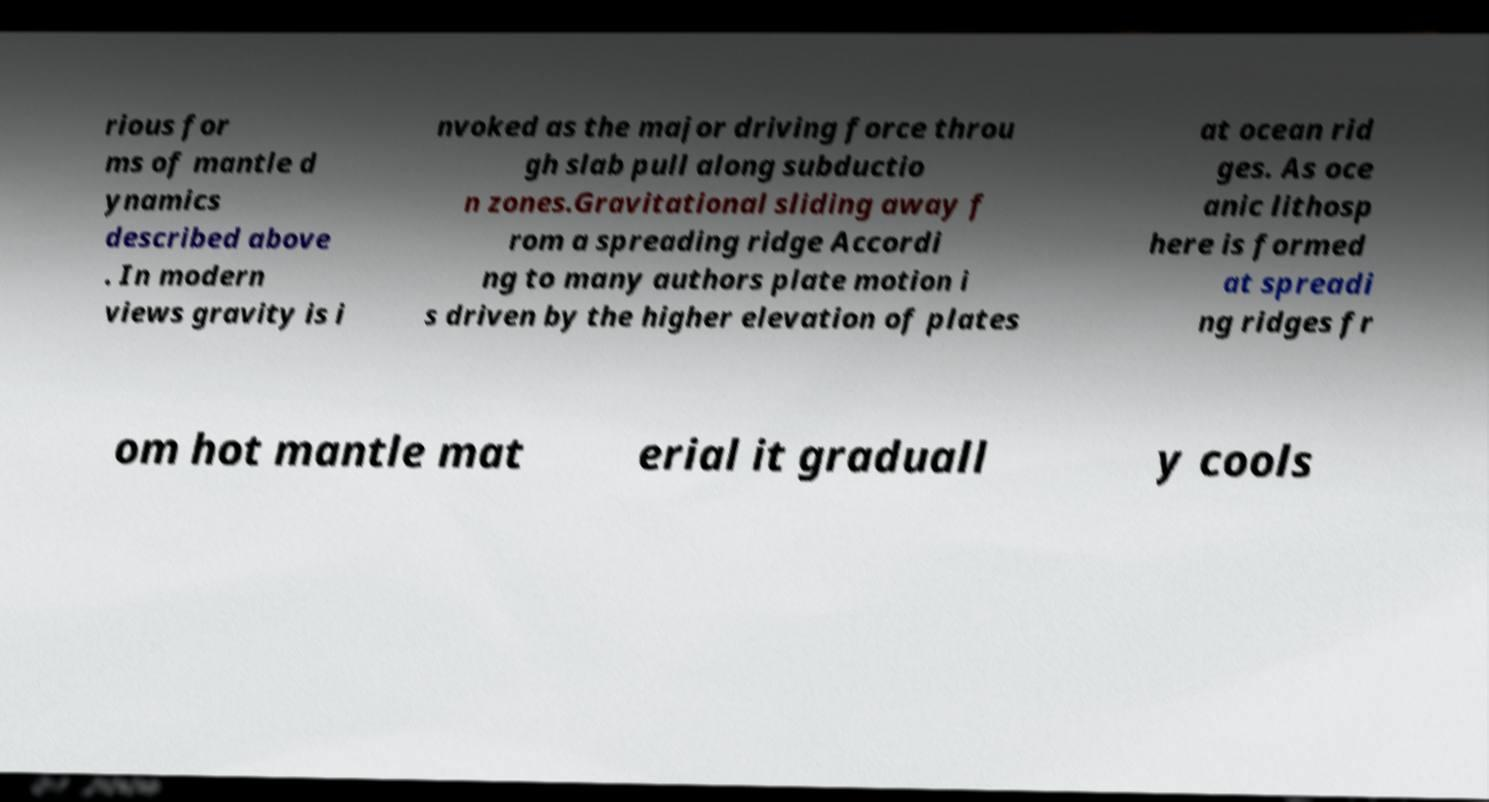I need the written content from this picture converted into text. Can you do that? rious for ms of mantle d ynamics described above . In modern views gravity is i nvoked as the major driving force throu gh slab pull along subductio n zones.Gravitational sliding away f rom a spreading ridge Accordi ng to many authors plate motion i s driven by the higher elevation of plates at ocean rid ges. As oce anic lithosp here is formed at spreadi ng ridges fr om hot mantle mat erial it graduall y cools 